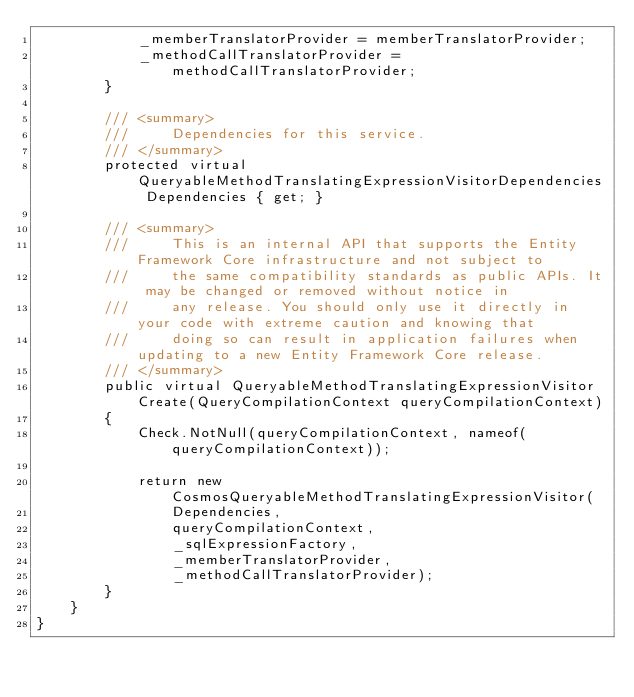Convert code to text. <code><loc_0><loc_0><loc_500><loc_500><_C#_>            _memberTranslatorProvider = memberTranslatorProvider;
            _methodCallTranslatorProvider = methodCallTranslatorProvider;
        }

        /// <summary>
        ///     Dependencies for this service.
        /// </summary>
        protected virtual QueryableMethodTranslatingExpressionVisitorDependencies Dependencies { get; }

        /// <summary>
        ///     This is an internal API that supports the Entity Framework Core infrastructure and not subject to
        ///     the same compatibility standards as public APIs. It may be changed or removed without notice in
        ///     any release. You should only use it directly in your code with extreme caution and knowing that
        ///     doing so can result in application failures when updating to a new Entity Framework Core release.
        /// </summary>
        public virtual QueryableMethodTranslatingExpressionVisitor Create(QueryCompilationContext queryCompilationContext)
        {
            Check.NotNull(queryCompilationContext, nameof(queryCompilationContext));

            return new CosmosQueryableMethodTranslatingExpressionVisitor(
                Dependencies,
                queryCompilationContext,
                _sqlExpressionFactory,
                _memberTranslatorProvider,
                _methodCallTranslatorProvider);
        }
    }
}
</code> 